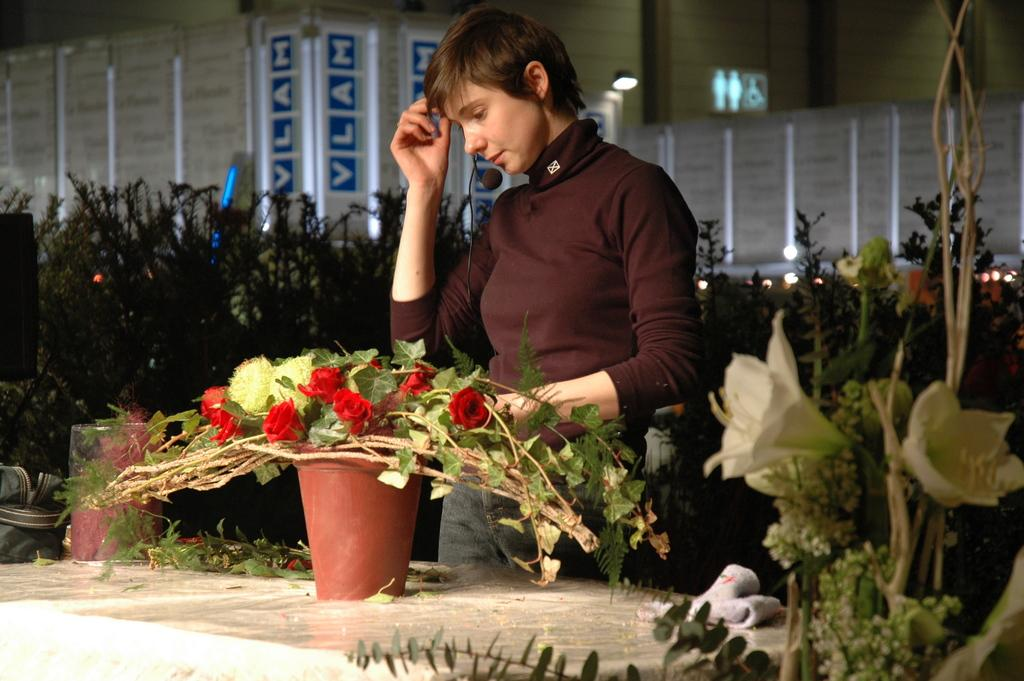What is the main subject of the image? There is a woman standing in the image. What is located in front of the woman? Flowers and a pot are present in front of the woman. What can be seen on the surface in front of the woman? There are objects on the surface in front of the woman. What is visible in the background of the image? The background of the image includes plants, a wall, and lights. What type of shoes is the woman wearing in the image? There is no information about the woman's shoes in the image, so we cannot determine what type she is wearing. 